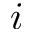Convert formula to latex. <formula><loc_0><loc_0><loc_500><loc_500>\romannumeral 1</formula> 